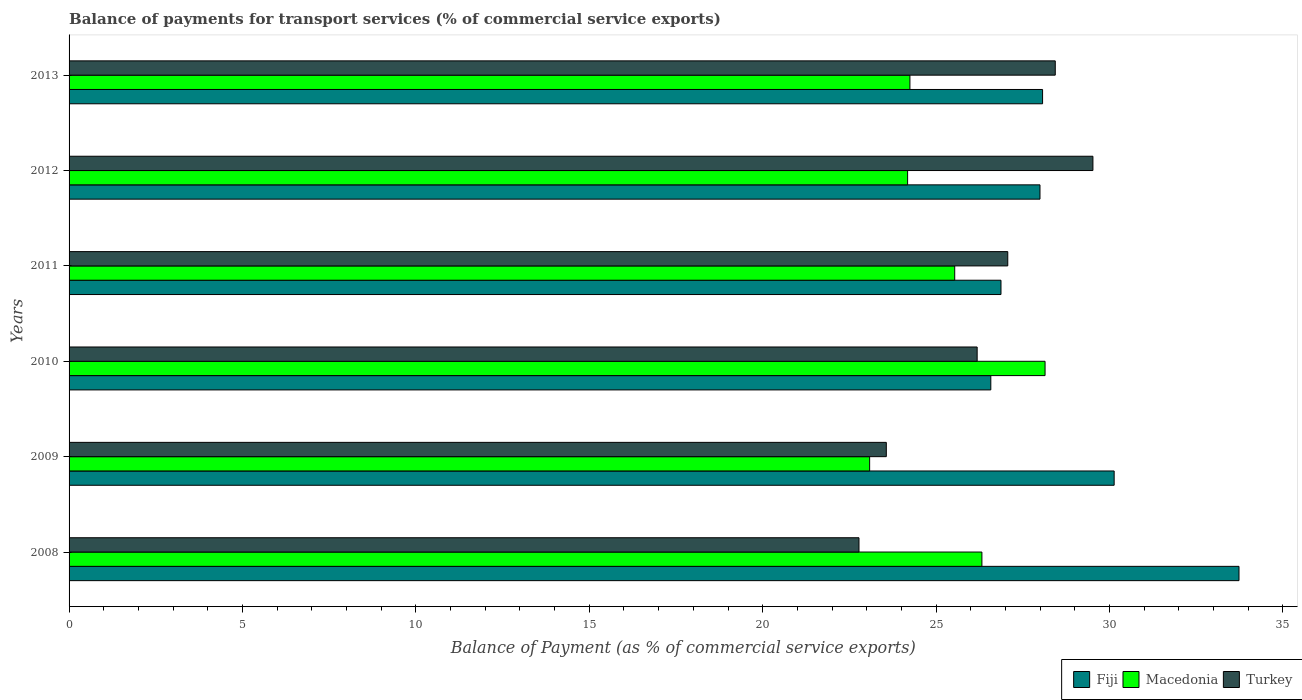How many different coloured bars are there?
Provide a succinct answer. 3. How many groups of bars are there?
Provide a short and direct response. 6. Are the number of bars per tick equal to the number of legend labels?
Make the answer very short. Yes. Are the number of bars on each tick of the Y-axis equal?
Your answer should be very brief. Yes. How many bars are there on the 5th tick from the bottom?
Ensure brevity in your answer.  3. What is the label of the 3rd group of bars from the top?
Your response must be concise. 2011. In how many cases, is the number of bars for a given year not equal to the number of legend labels?
Ensure brevity in your answer.  0. What is the balance of payments for transport services in Turkey in 2012?
Your answer should be compact. 29.52. Across all years, what is the maximum balance of payments for transport services in Macedonia?
Offer a very short reply. 28.14. Across all years, what is the minimum balance of payments for transport services in Fiji?
Make the answer very short. 26.58. What is the total balance of payments for transport services in Turkey in the graph?
Your answer should be very brief. 157.54. What is the difference between the balance of payments for transport services in Macedonia in 2008 and that in 2011?
Provide a succinct answer. 0.78. What is the difference between the balance of payments for transport services in Fiji in 2010 and the balance of payments for transport services in Macedonia in 2013?
Keep it short and to the point. 2.33. What is the average balance of payments for transport services in Fiji per year?
Make the answer very short. 28.9. In the year 2013, what is the difference between the balance of payments for transport services in Macedonia and balance of payments for transport services in Fiji?
Your response must be concise. -3.83. What is the ratio of the balance of payments for transport services in Turkey in 2008 to that in 2011?
Make the answer very short. 0.84. Is the balance of payments for transport services in Macedonia in 2010 less than that in 2012?
Your answer should be compact. No. Is the difference between the balance of payments for transport services in Macedonia in 2012 and 2013 greater than the difference between the balance of payments for transport services in Fiji in 2012 and 2013?
Keep it short and to the point. Yes. What is the difference between the highest and the second highest balance of payments for transport services in Turkey?
Your answer should be compact. 1.09. What is the difference between the highest and the lowest balance of payments for transport services in Macedonia?
Offer a terse response. 5.06. Is the sum of the balance of payments for transport services in Turkey in 2011 and 2013 greater than the maximum balance of payments for transport services in Macedonia across all years?
Offer a terse response. Yes. What does the 1st bar from the top in 2009 represents?
Ensure brevity in your answer.  Turkey. Is it the case that in every year, the sum of the balance of payments for transport services in Turkey and balance of payments for transport services in Fiji is greater than the balance of payments for transport services in Macedonia?
Make the answer very short. Yes. How many bars are there?
Provide a short and direct response. 18. How many years are there in the graph?
Provide a short and direct response. 6. What is the difference between two consecutive major ticks on the X-axis?
Your answer should be very brief. 5. Are the values on the major ticks of X-axis written in scientific E-notation?
Make the answer very short. No. Does the graph contain any zero values?
Ensure brevity in your answer.  No. Does the graph contain grids?
Provide a succinct answer. No. What is the title of the graph?
Your response must be concise. Balance of payments for transport services (% of commercial service exports). Does "Ecuador" appear as one of the legend labels in the graph?
Provide a succinct answer. No. What is the label or title of the X-axis?
Give a very brief answer. Balance of Payment (as % of commercial service exports). What is the Balance of Payment (as % of commercial service exports) in Fiji in 2008?
Offer a very short reply. 33.73. What is the Balance of Payment (as % of commercial service exports) of Macedonia in 2008?
Give a very brief answer. 26.32. What is the Balance of Payment (as % of commercial service exports) of Turkey in 2008?
Make the answer very short. 22.78. What is the Balance of Payment (as % of commercial service exports) of Fiji in 2009?
Make the answer very short. 30.13. What is the Balance of Payment (as % of commercial service exports) of Macedonia in 2009?
Provide a short and direct response. 23.08. What is the Balance of Payment (as % of commercial service exports) of Turkey in 2009?
Keep it short and to the point. 23.56. What is the Balance of Payment (as % of commercial service exports) of Fiji in 2010?
Your response must be concise. 26.58. What is the Balance of Payment (as % of commercial service exports) in Macedonia in 2010?
Your answer should be very brief. 28.14. What is the Balance of Payment (as % of commercial service exports) of Turkey in 2010?
Provide a short and direct response. 26.18. What is the Balance of Payment (as % of commercial service exports) in Fiji in 2011?
Offer a very short reply. 26.87. What is the Balance of Payment (as % of commercial service exports) of Macedonia in 2011?
Provide a short and direct response. 25.54. What is the Balance of Payment (as % of commercial service exports) in Turkey in 2011?
Give a very brief answer. 27.07. What is the Balance of Payment (as % of commercial service exports) of Fiji in 2012?
Your response must be concise. 27.99. What is the Balance of Payment (as % of commercial service exports) of Macedonia in 2012?
Ensure brevity in your answer.  24.18. What is the Balance of Payment (as % of commercial service exports) of Turkey in 2012?
Give a very brief answer. 29.52. What is the Balance of Payment (as % of commercial service exports) in Fiji in 2013?
Make the answer very short. 28.07. What is the Balance of Payment (as % of commercial service exports) in Macedonia in 2013?
Offer a terse response. 24.24. What is the Balance of Payment (as % of commercial service exports) in Turkey in 2013?
Your response must be concise. 28.43. Across all years, what is the maximum Balance of Payment (as % of commercial service exports) in Fiji?
Your response must be concise. 33.73. Across all years, what is the maximum Balance of Payment (as % of commercial service exports) in Macedonia?
Offer a very short reply. 28.14. Across all years, what is the maximum Balance of Payment (as % of commercial service exports) in Turkey?
Your answer should be compact. 29.52. Across all years, what is the minimum Balance of Payment (as % of commercial service exports) in Fiji?
Keep it short and to the point. 26.58. Across all years, what is the minimum Balance of Payment (as % of commercial service exports) in Macedonia?
Offer a very short reply. 23.08. Across all years, what is the minimum Balance of Payment (as % of commercial service exports) in Turkey?
Your response must be concise. 22.78. What is the total Balance of Payment (as % of commercial service exports) in Fiji in the graph?
Keep it short and to the point. 173.38. What is the total Balance of Payment (as % of commercial service exports) in Macedonia in the graph?
Your answer should be compact. 151.5. What is the total Balance of Payment (as % of commercial service exports) of Turkey in the graph?
Provide a short and direct response. 157.54. What is the difference between the Balance of Payment (as % of commercial service exports) in Fiji in 2008 and that in 2009?
Your response must be concise. 3.6. What is the difference between the Balance of Payment (as % of commercial service exports) in Macedonia in 2008 and that in 2009?
Your answer should be compact. 3.24. What is the difference between the Balance of Payment (as % of commercial service exports) of Turkey in 2008 and that in 2009?
Provide a succinct answer. -0.79. What is the difference between the Balance of Payment (as % of commercial service exports) of Fiji in 2008 and that in 2010?
Offer a very short reply. 7.16. What is the difference between the Balance of Payment (as % of commercial service exports) of Macedonia in 2008 and that in 2010?
Ensure brevity in your answer.  -1.82. What is the difference between the Balance of Payment (as % of commercial service exports) in Turkey in 2008 and that in 2010?
Your answer should be compact. -3.41. What is the difference between the Balance of Payment (as % of commercial service exports) in Fiji in 2008 and that in 2011?
Offer a very short reply. 6.86. What is the difference between the Balance of Payment (as % of commercial service exports) in Macedonia in 2008 and that in 2011?
Offer a terse response. 0.78. What is the difference between the Balance of Payment (as % of commercial service exports) in Turkey in 2008 and that in 2011?
Provide a short and direct response. -4.29. What is the difference between the Balance of Payment (as % of commercial service exports) of Fiji in 2008 and that in 2012?
Keep it short and to the point. 5.74. What is the difference between the Balance of Payment (as % of commercial service exports) in Macedonia in 2008 and that in 2012?
Provide a succinct answer. 2.14. What is the difference between the Balance of Payment (as % of commercial service exports) of Turkey in 2008 and that in 2012?
Offer a terse response. -6.75. What is the difference between the Balance of Payment (as % of commercial service exports) in Fiji in 2008 and that in 2013?
Offer a terse response. 5.66. What is the difference between the Balance of Payment (as % of commercial service exports) of Macedonia in 2008 and that in 2013?
Your answer should be compact. 2.08. What is the difference between the Balance of Payment (as % of commercial service exports) in Turkey in 2008 and that in 2013?
Your answer should be compact. -5.66. What is the difference between the Balance of Payment (as % of commercial service exports) in Fiji in 2009 and that in 2010?
Offer a very short reply. 3.56. What is the difference between the Balance of Payment (as % of commercial service exports) of Macedonia in 2009 and that in 2010?
Your answer should be compact. -5.06. What is the difference between the Balance of Payment (as % of commercial service exports) in Turkey in 2009 and that in 2010?
Provide a short and direct response. -2.62. What is the difference between the Balance of Payment (as % of commercial service exports) in Fiji in 2009 and that in 2011?
Your response must be concise. 3.26. What is the difference between the Balance of Payment (as % of commercial service exports) of Macedonia in 2009 and that in 2011?
Provide a succinct answer. -2.45. What is the difference between the Balance of Payment (as % of commercial service exports) in Turkey in 2009 and that in 2011?
Your answer should be compact. -3.5. What is the difference between the Balance of Payment (as % of commercial service exports) in Fiji in 2009 and that in 2012?
Offer a terse response. 2.14. What is the difference between the Balance of Payment (as % of commercial service exports) of Macedonia in 2009 and that in 2012?
Provide a succinct answer. -1.09. What is the difference between the Balance of Payment (as % of commercial service exports) of Turkey in 2009 and that in 2012?
Keep it short and to the point. -5.96. What is the difference between the Balance of Payment (as % of commercial service exports) of Fiji in 2009 and that in 2013?
Offer a very short reply. 2.06. What is the difference between the Balance of Payment (as % of commercial service exports) of Macedonia in 2009 and that in 2013?
Provide a succinct answer. -1.16. What is the difference between the Balance of Payment (as % of commercial service exports) of Turkey in 2009 and that in 2013?
Your answer should be very brief. -4.87. What is the difference between the Balance of Payment (as % of commercial service exports) of Fiji in 2010 and that in 2011?
Make the answer very short. -0.29. What is the difference between the Balance of Payment (as % of commercial service exports) in Macedonia in 2010 and that in 2011?
Give a very brief answer. 2.6. What is the difference between the Balance of Payment (as % of commercial service exports) in Turkey in 2010 and that in 2011?
Make the answer very short. -0.88. What is the difference between the Balance of Payment (as % of commercial service exports) of Fiji in 2010 and that in 2012?
Make the answer very short. -1.42. What is the difference between the Balance of Payment (as % of commercial service exports) in Macedonia in 2010 and that in 2012?
Provide a short and direct response. 3.96. What is the difference between the Balance of Payment (as % of commercial service exports) of Turkey in 2010 and that in 2012?
Keep it short and to the point. -3.34. What is the difference between the Balance of Payment (as % of commercial service exports) in Fiji in 2010 and that in 2013?
Provide a short and direct response. -1.49. What is the difference between the Balance of Payment (as % of commercial service exports) of Macedonia in 2010 and that in 2013?
Provide a short and direct response. 3.9. What is the difference between the Balance of Payment (as % of commercial service exports) in Turkey in 2010 and that in 2013?
Offer a very short reply. -2.25. What is the difference between the Balance of Payment (as % of commercial service exports) of Fiji in 2011 and that in 2012?
Give a very brief answer. -1.12. What is the difference between the Balance of Payment (as % of commercial service exports) of Macedonia in 2011 and that in 2012?
Give a very brief answer. 1.36. What is the difference between the Balance of Payment (as % of commercial service exports) in Turkey in 2011 and that in 2012?
Keep it short and to the point. -2.46. What is the difference between the Balance of Payment (as % of commercial service exports) in Fiji in 2011 and that in 2013?
Provide a short and direct response. -1.2. What is the difference between the Balance of Payment (as % of commercial service exports) in Macedonia in 2011 and that in 2013?
Your answer should be compact. 1.29. What is the difference between the Balance of Payment (as % of commercial service exports) in Turkey in 2011 and that in 2013?
Provide a succinct answer. -1.37. What is the difference between the Balance of Payment (as % of commercial service exports) in Fiji in 2012 and that in 2013?
Your response must be concise. -0.07. What is the difference between the Balance of Payment (as % of commercial service exports) of Macedonia in 2012 and that in 2013?
Make the answer very short. -0.07. What is the difference between the Balance of Payment (as % of commercial service exports) of Turkey in 2012 and that in 2013?
Ensure brevity in your answer.  1.09. What is the difference between the Balance of Payment (as % of commercial service exports) in Fiji in 2008 and the Balance of Payment (as % of commercial service exports) in Macedonia in 2009?
Your response must be concise. 10.65. What is the difference between the Balance of Payment (as % of commercial service exports) of Fiji in 2008 and the Balance of Payment (as % of commercial service exports) of Turkey in 2009?
Provide a short and direct response. 10.17. What is the difference between the Balance of Payment (as % of commercial service exports) of Macedonia in 2008 and the Balance of Payment (as % of commercial service exports) of Turkey in 2009?
Give a very brief answer. 2.76. What is the difference between the Balance of Payment (as % of commercial service exports) of Fiji in 2008 and the Balance of Payment (as % of commercial service exports) of Macedonia in 2010?
Give a very brief answer. 5.59. What is the difference between the Balance of Payment (as % of commercial service exports) of Fiji in 2008 and the Balance of Payment (as % of commercial service exports) of Turkey in 2010?
Offer a very short reply. 7.55. What is the difference between the Balance of Payment (as % of commercial service exports) in Macedonia in 2008 and the Balance of Payment (as % of commercial service exports) in Turkey in 2010?
Offer a very short reply. 0.14. What is the difference between the Balance of Payment (as % of commercial service exports) of Fiji in 2008 and the Balance of Payment (as % of commercial service exports) of Macedonia in 2011?
Provide a succinct answer. 8.2. What is the difference between the Balance of Payment (as % of commercial service exports) of Fiji in 2008 and the Balance of Payment (as % of commercial service exports) of Turkey in 2011?
Keep it short and to the point. 6.67. What is the difference between the Balance of Payment (as % of commercial service exports) in Macedonia in 2008 and the Balance of Payment (as % of commercial service exports) in Turkey in 2011?
Offer a terse response. -0.75. What is the difference between the Balance of Payment (as % of commercial service exports) in Fiji in 2008 and the Balance of Payment (as % of commercial service exports) in Macedonia in 2012?
Keep it short and to the point. 9.55. What is the difference between the Balance of Payment (as % of commercial service exports) of Fiji in 2008 and the Balance of Payment (as % of commercial service exports) of Turkey in 2012?
Offer a terse response. 4.21. What is the difference between the Balance of Payment (as % of commercial service exports) in Macedonia in 2008 and the Balance of Payment (as % of commercial service exports) in Turkey in 2012?
Provide a succinct answer. -3.2. What is the difference between the Balance of Payment (as % of commercial service exports) in Fiji in 2008 and the Balance of Payment (as % of commercial service exports) in Macedonia in 2013?
Your answer should be very brief. 9.49. What is the difference between the Balance of Payment (as % of commercial service exports) in Fiji in 2008 and the Balance of Payment (as % of commercial service exports) in Turkey in 2013?
Your answer should be very brief. 5.3. What is the difference between the Balance of Payment (as % of commercial service exports) of Macedonia in 2008 and the Balance of Payment (as % of commercial service exports) of Turkey in 2013?
Provide a short and direct response. -2.12. What is the difference between the Balance of Payment (as % of commercial service exports) of Fiji in 2009 and the Balance of Payment (as % of commercial service exports) of Macedonia in 2010?
Keep it short and to the point. 1.99. What is the difference between the Balance of Payment (as % of commercial service exports) in Fiji in 2009 and the Balance of Payment (as % of commercial service exports) in Turkey in 2010?
Make the answer very short. 3.95. What is the difference between the Balance of Payment (as % of commercial service exports) in Macedonia in 2009 and the Balance of Payment (as % of commercial service exports) in Turkey in 2010?
Offer a very short reply. -3.1. What is the difference between the Balance of Payment (as % of commercial service exports) in Fiji in 2009 and the Balance of Payment (as % of commercial service exports) in Macedonia in 2011?
Ensure brevity in your answer.  4.6. What is the difference between the Balance of Payment (as % of commercial service exports) in Fiji in 2009 and the Balance of Payment (as % of commercial service exports) in Turkey in 2011?
Ensure brevity in your answer.  3.07. What is the difference between the Balance of Payment (as % of commercial service exports) of Macedonia in 2009 and the Balance of Payment (as % of commercial service exports) of Turkey in 2011?
Ensure brevity in your answer.  -3.98. What is the difference between the Balance of Payment (as % of commercial service exports) in Fiji in 2009 and the Balance of Payment (as % of commercial service exports) in Macedonia in 2012?
Offer a terse response. 5.96. What is the difference between the Balance of Payment (as % of commercial service exports) of Fiji in 2009 and the Balance of Payment (as % of commercial service exports) of Turkey in 2012?
Keep it short and to the point. 0.61. What is the difference between the Balance of Payment (as % of commercial service exports) of Macedonia in 2009 and the Balance of Payment (as % of commercial service exports) of Turkey in 2012?
Keep it short and to the point. -6.44. What is the difference between the Balance of Payment (as % of commercial service exports) in Fiji in 2009 and the Balance of Payment (as % of commercial service exports) in Macedonia in 2013?
Your answer should be compact. 5.89. What is the difference between the Balance of Payment (as % of commercial service exports) of Fiji in 2009 and the Balance of Payment (as % of commercial service exports) of Turkey in 2013?
Keep it short and to the point. 1.7. What is the difference between the Balance of Payment (as % of commercial service exports) in Macedonia in 2009 and the Balance of Payment (as % of commercial service exports) in Turkey in 2013?
Give a very brief answer. -5.35. What is the difference between the Balance of Payment (as % of commercial service exports) in Fiji in 2010 and the Balance of Payment (as % of commercial service exports) in Macedonia in 2011?
Offer a terse response. 1.04. What is the difference between the Balance of Payment (as % of commercial service exports) of Fiji in 2010 and the Balance of Payment (as % of commercial service exports) of Turkey in 2011?
Provide a succinct answer. -0.49. What is the difference between the Balance of Payment (as % of commercial service exports) of Macedonia in 2010 and the Balance of Payment (as % of commercial service exports) of Turkey in 2011?
Your response must be concise. 1.08. What is the difference between the Balance of Payment (as % of commercial service exports) in Fiji in 2010 and the Balance of Payment (as % of commercial service exports) in Macedonia in 2012?
Offer a terse response. 2.4. What is the difference between the Balance of Payment (as % of commercial service exports) of Fiji in 2010 and the Balance of Payment (as % of commercial service exports) of Turkey in 2012?
Offer a terse response. -2.94. What is the difference between the Balance of Payment (as % of commercial service exports) in Macedonia in 2010 and the Balance of Payment (as % of commercial service exports) in Turkey in 2012?
Provide a succinct answer. -1.38. What is the difference between the Balance of Payment (as % of commercial service exports) in Fiji in 2010 and the Balance of Payment (as % of commercial service exports) in Macedonia in 2013?
Ensure brevity in your answer.  2.33. What is the difference between the Balance of Payment (as % of commercial service exports) in Fiji in 2010 and the Balance of Payment (as % of commercial service exports) in Turkey in 2013?
Keep it short and to the point. -1.86. What is the difference between the Balance of Payment (as % of commercial service exports) of Macedonia in 2010 and the Balance of Payment (as % of commercial service exports) of Turkey in 2013?
Provide a succinct answer. -0.29. What is the difference between the Balance of Payment (as % of commercial service exports) of Fiji in 2011 and the Balance of Payment (as % of commercial service exports) of Macedonia in 2012?
Your answer should be very brief. 2.69. What is the difference between the Balance of Payment (as % of commercial service exports) in Fiji in 2011 and the Balance of Payment (as % of commercial service exports) in Turkey in 2012?
Your answer should be compact. -2.65. What is the difference between the Balance of Payment (as % of commercial service exports) of Macedonia in 2011 and the Balance of Payment (as % of commercial service exports) of Turkey in 2012?
Provide a succinct answer. -3.98. What is the difference between the Balance of Payment (as % of commercial service exports) of Fiji in 2011 and the Balance of Payment (as % of commercial service exports) of Macedonia in 2013?
Your answer should be very brief. 2.63. What is the difference between the Balance of Payment (as % of commercial service exports) in Fiji in 2011 and the Balance of Payment (as % of commercial service exports) in Turkey in 2013?
Make the answer very short. -1.56. What is the difference between the Balance of Payment (as % of commercial service exports) in Macedonia in 2011 and the Balance of Payment (as % of commercial service exports) in Turkey in 2013?
Your answer should be very brief. -2.9. What is the difference between the Balance of Payment (as % of commercial service exports) of Fiji in 2012 and the Balance of Payment (as % of commercial service exports) of Macedonia in 2013?
Give a very brief answer. 3.75. What is the difference between the Balance of Payment (as % of commercial service exports) of Fiji in 2012 and the Balance of Payment (as % of commercial service exports) of Turkey in 2013?
Provide a short and direct response. -0.44. What is the difference between the Balance of Payment (as % of commercial service exports) of Macedonia in 2012 and the Balance of Payment (as % of commercial service exports) of Turkey in 2013?
Make the answer very short. -4.26. What is the average Balance of Payment (as % of commercial service exports) in Fiji per year?
Make the answer very short. 28.9. What is the average Balance of Payment (as % of commercial service exports) of Macedonia per year?
Your answer should be very brief. 25.25. What is the average Balance of Payment (as % of commercial service exports) of Turkey per year?
Provide a succinct answer. 26.26. In the year 2008, what is the difference between the Balance of Payment (as % of commercial service exports) in Fiji and Balance of Payment (as % of commercial service exports) in Macedonia?
Your answer should be compact. 7.41. In the year 2008, what is the difference between the Balance of Payment (as % of commercial service exports) of Fiji and Balance of Payment (as % of commercial service exports) of Turkey?
Provide a short and direct response. 10.96. In the year 2008, what is the difference between the Balance of Payment (as % of commercial service exports) in Macedonia and Balance of Payment (as % of commercial service exports) in Turkey?
Your response must be concise. 3.54. In the year 2009, what is the difference between the Balance of Payment (as % of commercial service exports) of Fiji and Balance of Payment (as % of commercial service exports) of Macedonia?
Offer a terse response. 7.05. In the year 2009, what is the difference between the Balance of Payment (as % of commercial service exports) of Fiji and Balance of Payment (as % of commercial service exports) of Turkey?
Provide a short and direct response. 6.57. In the year 2009, what is the difference between the Balance of Payment (as % of commercial service exports) in Macedonia and Balance of Payment (as % of commercial service exports) in Turkey?
Your answer should be compact. -0.48. In the year 2010, what is the difference between the Balance of Payment (as % of commercial service exports) in Fiji and Balance of Payment (as % of commercial service exports) in Macedonia?
Provide a short and direct response. -1.56. In the year 2010, what is the difference between the Balance of Payment (as % of commercial service exports) of Fiji and Balance of Payment (as % of commercial service exports) of Turkey?
Keep it short and to the point. 0.39. In the year 2010, what is the difference between the Balance of Payment (as % of commercial service exports) of Macedonia and Balance of Payment (as % of commercial service exports) of Turkey?
Your answer should be very brief. 1.96. In the year 2011, what is the difference between the Balance of Payment (as % of commercial service exports) of Fiji and Balance of Payment (as % of commercial service exports) of Macedonia?
Offer a terse response. 1.33. In the year 2011, what is the difference between the Balance of Payment (as % of commercial service exports) of Fiji and Balance of Payment (as % of commercial service exports) of Turkey?
Provide a succinct answer. -0.2. In the year 2011, what is the difference between the Balance of Payment (as % of commercial service exports) in Macedonia and Balance of Payment (as % of commercial service exports) in Turkey?
Offer a very short reply. -1.53. In the year 2012, what is the difference between the Balance of Payment (as % of commercial service exports) in Fiji and Balance of Payment (as % of commercial service exports) in Macedonia?
Make the answer very short. 3.82. In the year 2012, what is the difference between the Balance of Payment (as % of commercial service exports) of Fiji and Balance of Payment (as % of commercial service exports) of Turkey?
Offer a very short reply. -1.53. In the year 2012, what is the difference between the Balance of Payment (as % of commercial service exports) of Macedonia and Balance of Payment (as % of commercial service exports) of Turkey?
Offer a very short reply. -5.34. In the year 2013, what is the difference between the Balance of Payment (as % of commercial service exports) in Fiji and Balance of Payment (as % of commercial service exports) in Macedonia?
Provide a succinct answer. 3.83. In the year 2013, what is the difference between the Balance of Payment (as % of commercial service exports) of Fiji and Balance of Payment (as % of commercial service exports) of Turkey?
Your answer should be very brief. -0.37. In the year 2013, what is the difference between the Balance of Payment (as % of commercial service exports) of Macedonia and Balance of Payment (as % of commercial service exports) of Turkey?
Your response must be concise. -4.19. What is the ratio of the Balance of Payment (as % of commercial service exports) of Fiji in 2008 to that in 2009?
Ensure brevity in your answer.  1.12. What is the ratio of the Balance of Payment (as % of commercial service exports) in Macedonia in 2008 to that in 2009?
Make the answer very short. 1.14. What is the ratio of the Balance of Payment (as % of commercial service exports) of Turkey in 2008 to that in 2009?
Make the answer very short. 0.97. What is the ratio of the Balance of Payment (as % of commercial service exports) of Fiji in 2008 to that in 2010?
Provide a short and direct response. 1.27. What is the ratio of the Balance of Payment (as % of commercial service exports) in Macedonia in 2008 to that in 2010?
Give a very brief answer. 0.94. What is the ratio of the Balance of Payment (as % of commercial service exports) of Turkey in 2008 to that in 2010?
Your response must be concise. 0.87. What is the ratio of the Balance of Payment (as % of commercial service exports) in Fiji in 2008 to that in 2011?
Ensure brevity in your answer.  1.26. What is the ratio of the Balance of Payment (as % of commercial service exports) in Macedonia in 2008 to that in 2011?
Your answer should be compact. 1.03. What is the ratio of the Balance of Payment (as % of commercial service exports) in Turkey in 2008 to that in 2011?
Your answer should be compact. 0.84. What is the ratio of the Balance of Payment (as % of commercial service exports) in Fiji in 2008 to that in 2012?
Your answer should be very brief. 1.21. What is the ratio of the Balance of Payment (as % of commercial service exports) in Macedonia in 2008 to that in 2012?
Your answer should be compact. 1.09. What is the ratio of the Balance of Payment (as % of commercial service exports) in Turkey in 2008 to that in 2012?
Offer a very short reply. 0.77. What is the ratio of the Balance of Payment (as % of commercial service exports) in Fiji in 2008 to that in 2013?
Make the answer very short. 1.2. What is the ratio of the Balance of Payment (as % of commercial service exports) of Macedonia in 2008 to that in 2013?
Provide a succinct answer. 1.09. What is the ratio of the Balance of Payment (as % of commercial service exports) in Turkey in 2008 to that in 2013?
Offer a very short reply. 0.8. What is the ratio of the Balance of Payment (as % of commercial service exports) of Fiji in 2009 to that in 2010?
Your answer should be compact. 1.13. What is the ratio of the Balance of Payment (as % of commercial service exports) in Macedonia in 2009 to that in 2010?
Provide a short and direct response. 0.82. What is the ratio of the Balance of Payment (as % of commercial service exports) in Fiji in 2009 to that in 2011?
Offer a terse response. 1.12. What is the ratio of the Balance of Payment (as % of commercial service exports) in Macedonia in 2009 to that in 2011?
Give a very brief answer. 0.9. What is the ratio of the Balance of Payment (as % of commercial service exports) in Turkey in 2009 to that in 2011?
Ensure brevity in your answer.  0.87. What is the ratio of the Balance of Payment (as % of commercial service exports) in Fiji in 2009 to that in 2012?
Provide a short and direct response. 1.08. What is the ratio of the Balance of Payment (as % of commercial service exports) in Macedonia in 2009 to that in 2012?
Provide a short and direct response. 0.95. What is the ratio of the Balance of Payment (as % of commercial service exports) in Turkey in 2009 to that in 2012?
Ensure brevity in your answer.  0.8. What is the ratio of the Balance of Payment (as % of commercial service exports) of Fiji in 2009 to that in 2013?
Make the answer very short. 1.07. What is the ratio of the Balance of Payment (as % of commercial service exports) of Macedonia in 2009 to that in 2013?
Give a very brief answer. 0.95. What is the ratio of the Balance of Payment (as % of commercial service exports) in Turkey in 2009 to that in 2013?
Give a very brief answer. 0.83. What is the ratio of the Balance of Payment (as % of commercial service exports) of Macedonia in 2010 to that in 2011?
Your response must be concise. 1.1. What is the ratio of the Balance of Payment (as % of commercial service exports) of Turkey in 2010 to that in 2011?
Ensure brevity in your answer.  0.97. What is the ratio of the Balance of Payment (as % of commercial service exports) of Fiji in 2010 to that in 2012?
Your answer should be compact. 0.95. What is the ratio of the Balance of Payment (as % of commercial service exports) in Macedonia in 2010 to that in 2012?
Your answer should be compact. 1.16. What is the ratio of the Balance of Payment (as % of commercial service exports) in Turkey in 2010 to that in 2012?
Make the answer very short. 0.89. What is the ratio of the Balance of Payment (as % of commercial service exports) of Fiji in 2010 to that in 2013?
Offer a very short reply. 0.95. What is the ratio of the Balance of Payment (as % of commercial service exports) of Macedonia in 2010 to that in 2013?
Offer a terse response. 1.16. What is the ratio of the Balance of Payment (as % of commercial service exports) of Turkey in 2010 to that in 2013?
Offer a terse response. 0.92. What is the ratio of the Balance of Payment (as % of commercial service exports) of Fiji in 2011 to that in 2012?
Your response must be concise. 0.96. What is the ratio of the Balance of Payment (as % of commercial service exports) in Macedonia in 2011 to that in 2012?
Your answer should be very brief. 1.06. What is the ratio of the Balance of Payment (as % of commercial service exports) in Turkey in 2011 to that in 2012?
Your answer should be very brief. 0.92. What is the ratio of the Balance of Payment (as % of commercial service exports) in Fiji in 2011 to that in 2013?
Your answer should be compact. 0.96. What is the ratio of the Balance of Payment (as % of commercial service exports) in Macedonia in 2011 to that in 2013?
Offer a very short reply. 1.05. What is the ratio of the Balance of Payment (as % of commercial service exports) of Turkey in 2011 to that in 2013?
Ensure brevity in your answer.  0.95. What is the ratio of the Balance of Payment (as % of commercial service exports) of Turkey in 2012 to that in 2013?
Offer a very short reply. 1.04. What is the difference between the highest and the second highest Balance of Payment (as % of commercial service exports) in Fiji?
Offer a very short reply. 3.6. What is the difference between the highest and the second highest Balance of Payment (as % of commercial service exports) of Macedonia?
Keep it short and to the point. 1.82. What is the difference between the highest and the second highest Balance of Payment (as % of commercial service exports) in Turkey?
Offer a very short reply. 1.09. What is the difference between the highest and the lowest Balance of Payment (as % of commercial service exports) of Fiji?
Offer a very short reply. 7.16. What is the difference between the highest and the lowest Balance of Payment (as % of commercial service exports) in Macedonia?
Your response must be concise. 5.06. What is the difference between the highest and the lowest Balance of Payment (as % of commercial service exports) of Turkey?
Your response must be concise. 6.75. 